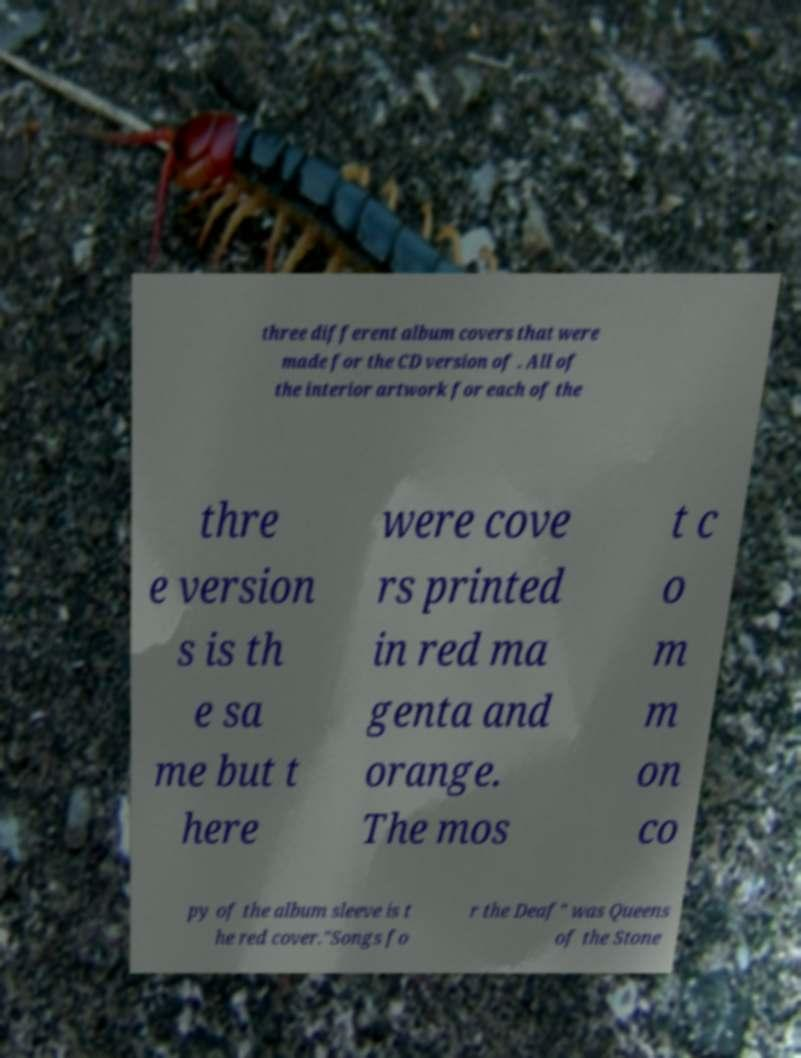For documentation purposes, I need the text within this image transcribed. Could you provide that? three different album covers that were made for the CD version of . All of the interior artwork for each of the thre e version s is th e sa me but t here were cove rs printed in red ma genta and orange. The mos t c o m m on co py of the album sleeve is t he red cover."Songs fo r the Deaf" was Queens of the Stone 